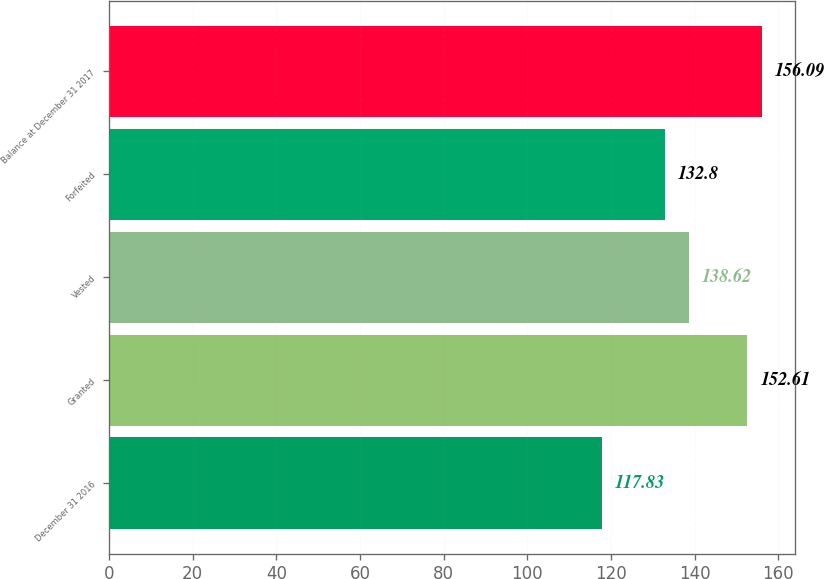Convert chart. <chart><loc_0><loc_0><loc_500><loc_500><bar_chart><fcel>December 31 2016<fcel>Granted<fcel>Vested<fcel>Forfeited<fcel>Balance at December 31 2017<nl><fcel>117.83<fcel>152.61<fcel>138.62<fcel>132.8<fcel>156.09<nl></chart> 